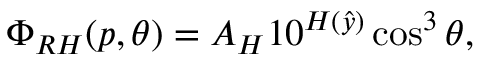Convert formula to latex. <formula><loc_0><loc_0><loc_500><loc_500>\Phi _ { R H } ( p , \theta ) = A _ { H } 1 0 ^ { H ( \hat { y } ) } \cos ^ { 3 } \theta ,</formula> 